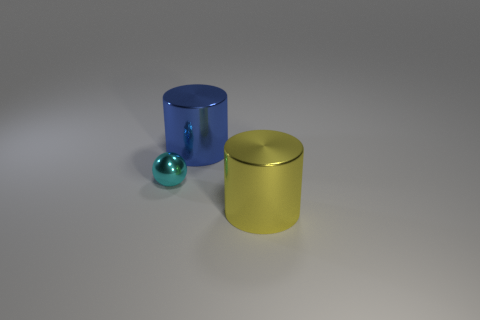The large cylinder that is in front of the large metal object to the left of the big yellow metal object is what color?
Your answer should be compact. Yellow. Is the number of tiny cyan spheres that are in front of the large blue metallic object less than the number of shiny things right of the small cyan object?
Your answer should be very brief. Yes. There is a blue metal cylinder; is its size the same as the metal object that is in front of the small cyan thing?
Ensure brevity in your answer.  Yes. The shiny object that is both in front of the large blue shiny object and to the right of the cyan sphere has what shape?
Provide a short and direct response. Cylinder. There is a sphere that is made of the same material as the big yellow thing; what is its size?
Your response must be concise. Small. How many metal spheres are on the right side of the small cyan sphere that is on the left side of the big blue cylinder?
Offer a very short reply. 0. How big is the shiny cylinder in front of the tiny shiny ball on the left side of the blue metallic object?
Make the answer very short. Large. What size is the ball that is behind the cylinder that is in front of the shiny object behind the metallic sphere?
Offer a terse response. Small. There is a big thing to the left of the yellow object; is its shape the same as the cyan shiny thing behind the large yellow metal cylinder?
Your answer should be compact. No. What number of other objects are the same color as the metallic ball?
Keep it short and to the point. 0. 